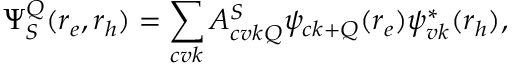<formula> <loc_0><loc_0><loc_500><loc_500>\Psi _ { S } ^ { Q } ( r _ { e } , r _ { h } ) = \sum _ { c v k } A _ { c v k Q } ^ { S } \psi _ { c k + Q } ( r _ { e } ) \psi _ { v k } ^ { * } ( r _ { h } ) ,</formula> 